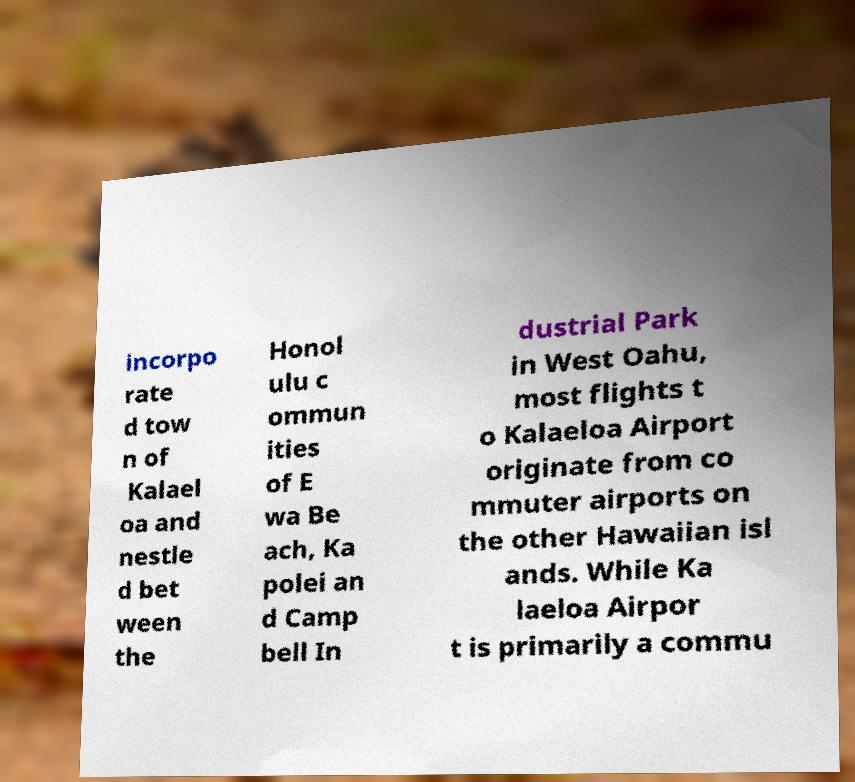Can you accurately transcribe the text from the provided image for me? incorpo rate d tow n of Kalael oa and nestle d bet ween the Honol ulu c ommun ities of E wa Be ach, Ka polei an d Camp bell In dustrial Park in West Oahu, most flights t o Kalaeloa Airport originate from co mmuter airports on the other Hawaiian isl ands. While Ka laeloa Airpor t is primarily a commu 